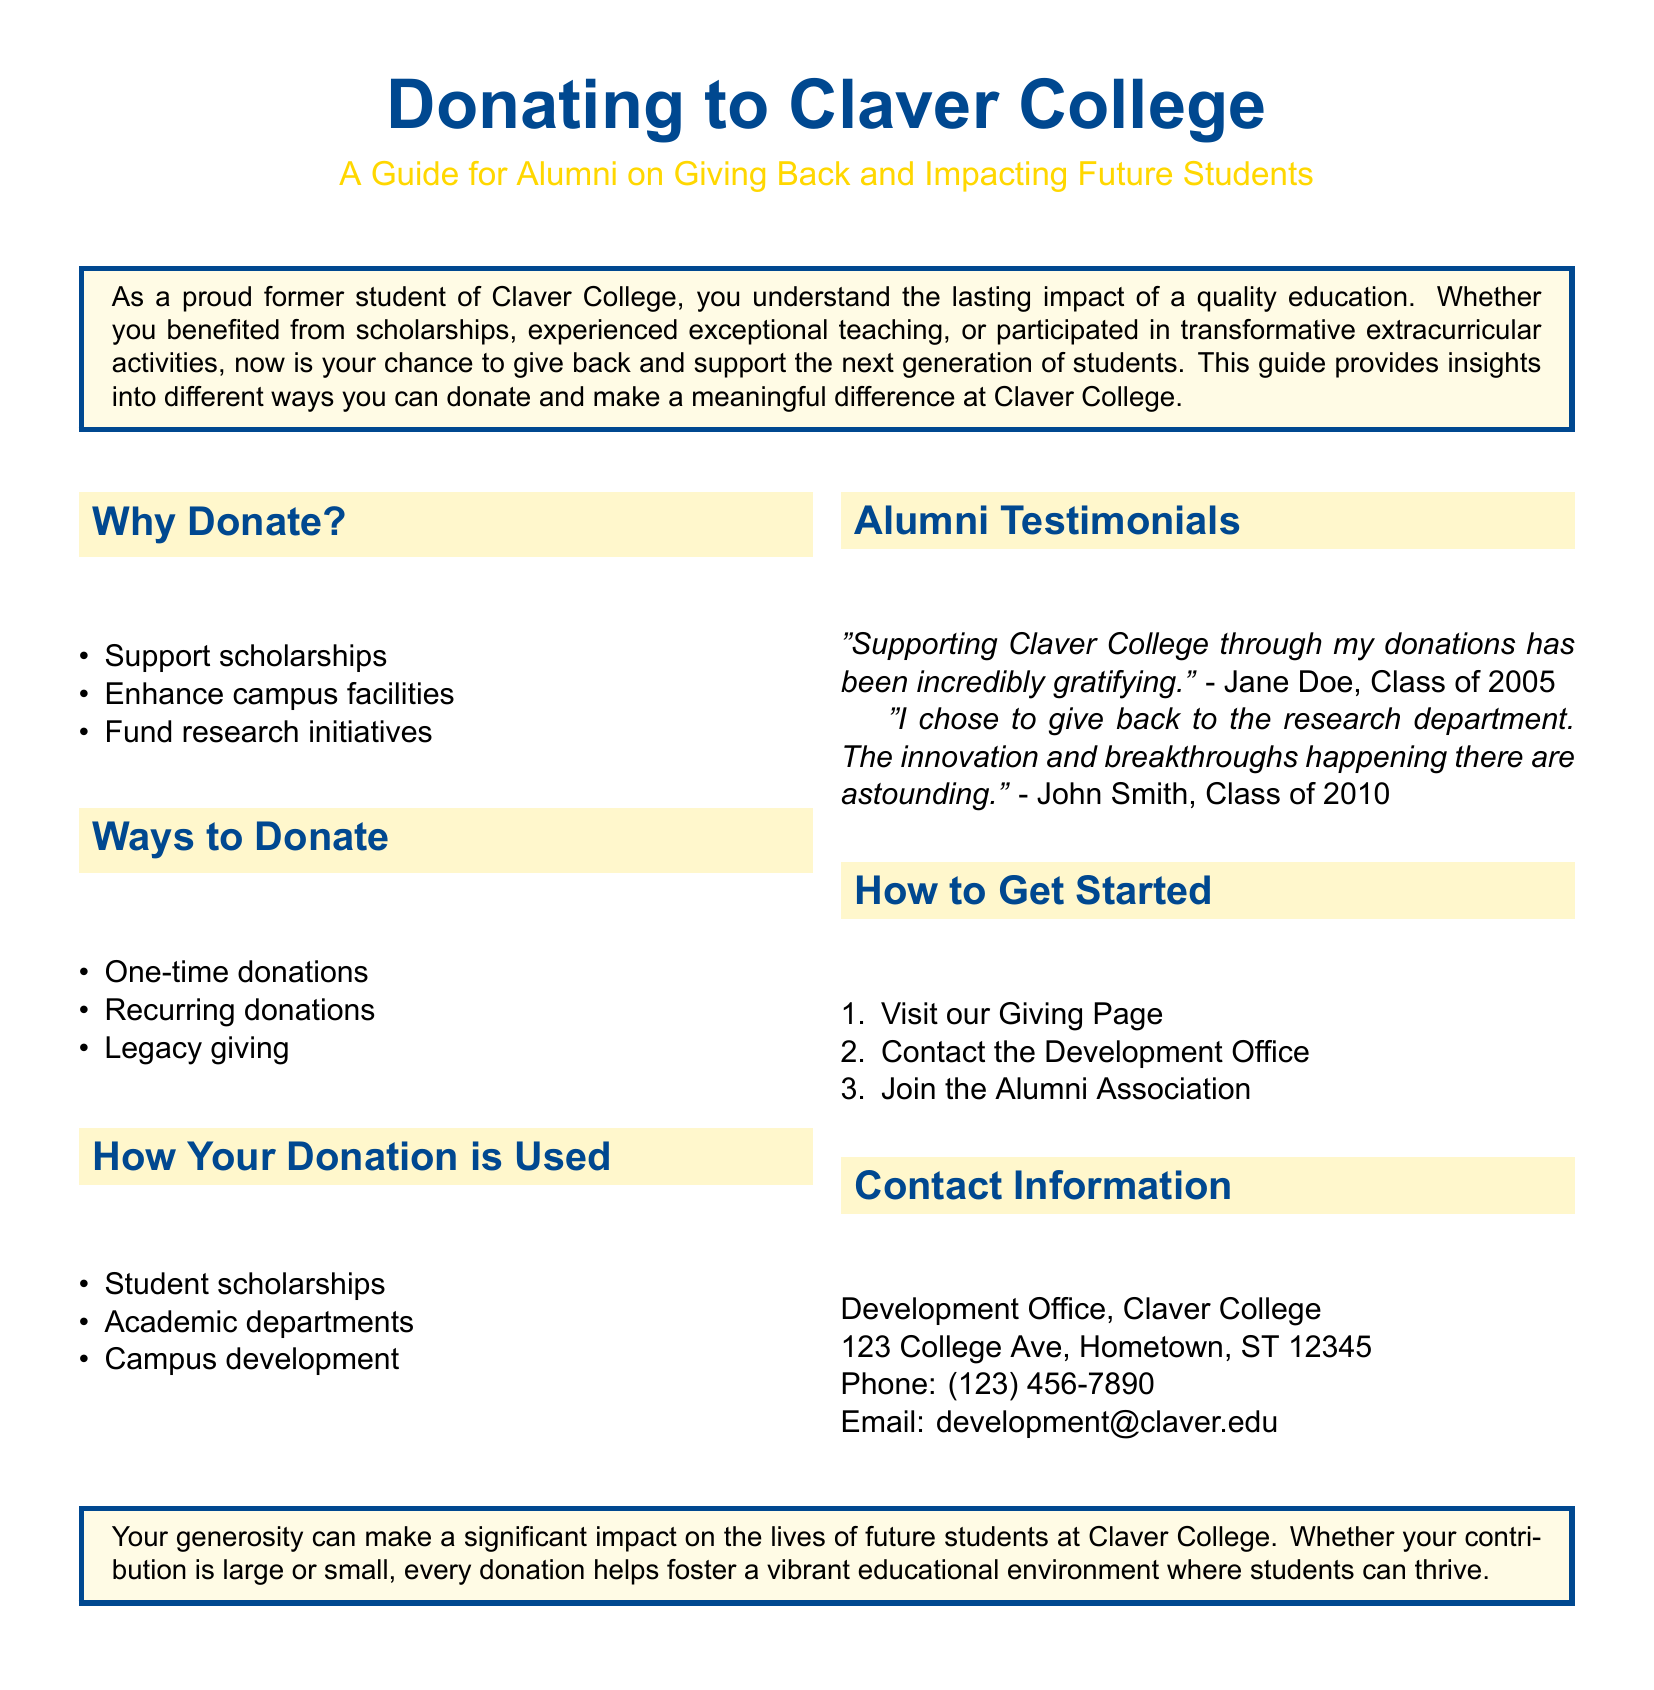What are three reasons to donate? The document lists three reasons to donate: support scholarships, enhance campus facilities, and fund research initiatives.
Answer: Support scholarships, enhance campus facilities, fund research initiatives What is one way to donate? The document mentions several ways to donate, including one-time donations, which is one example provided.
Answer: One-time donations How can you contact the Development Office? The contact information provided in the document includes a phone number and an email address for the Development Office.
Answer: Phone: (123) 456-7890; Email: development@claver.edu How many alumni testimonials are provided in the document? The document includes two alumni testimonials from Jane Doe and John Smith.
Answer: Two What is the address of Claver College's Development Office? The document provides a specific address for the Development Office of Claver College.
Answer: 123 College Ave, Hometown, ST 12345 What is the first step to get started with donating? The document outlines steps to get started, with the first step being to visit the Giving Page.
Answer: Visit our Giving Page Why is it important to donate according to the document? The document emphasizes the importance of generosity in making a significant impact on future students at Claver College.
Answer: To make a significant impact on future students What color is associated with Claver College in the document? The document has color themes, notably using a specific shade of blue identified as Claver Blue.
Answer: Claver Blue 